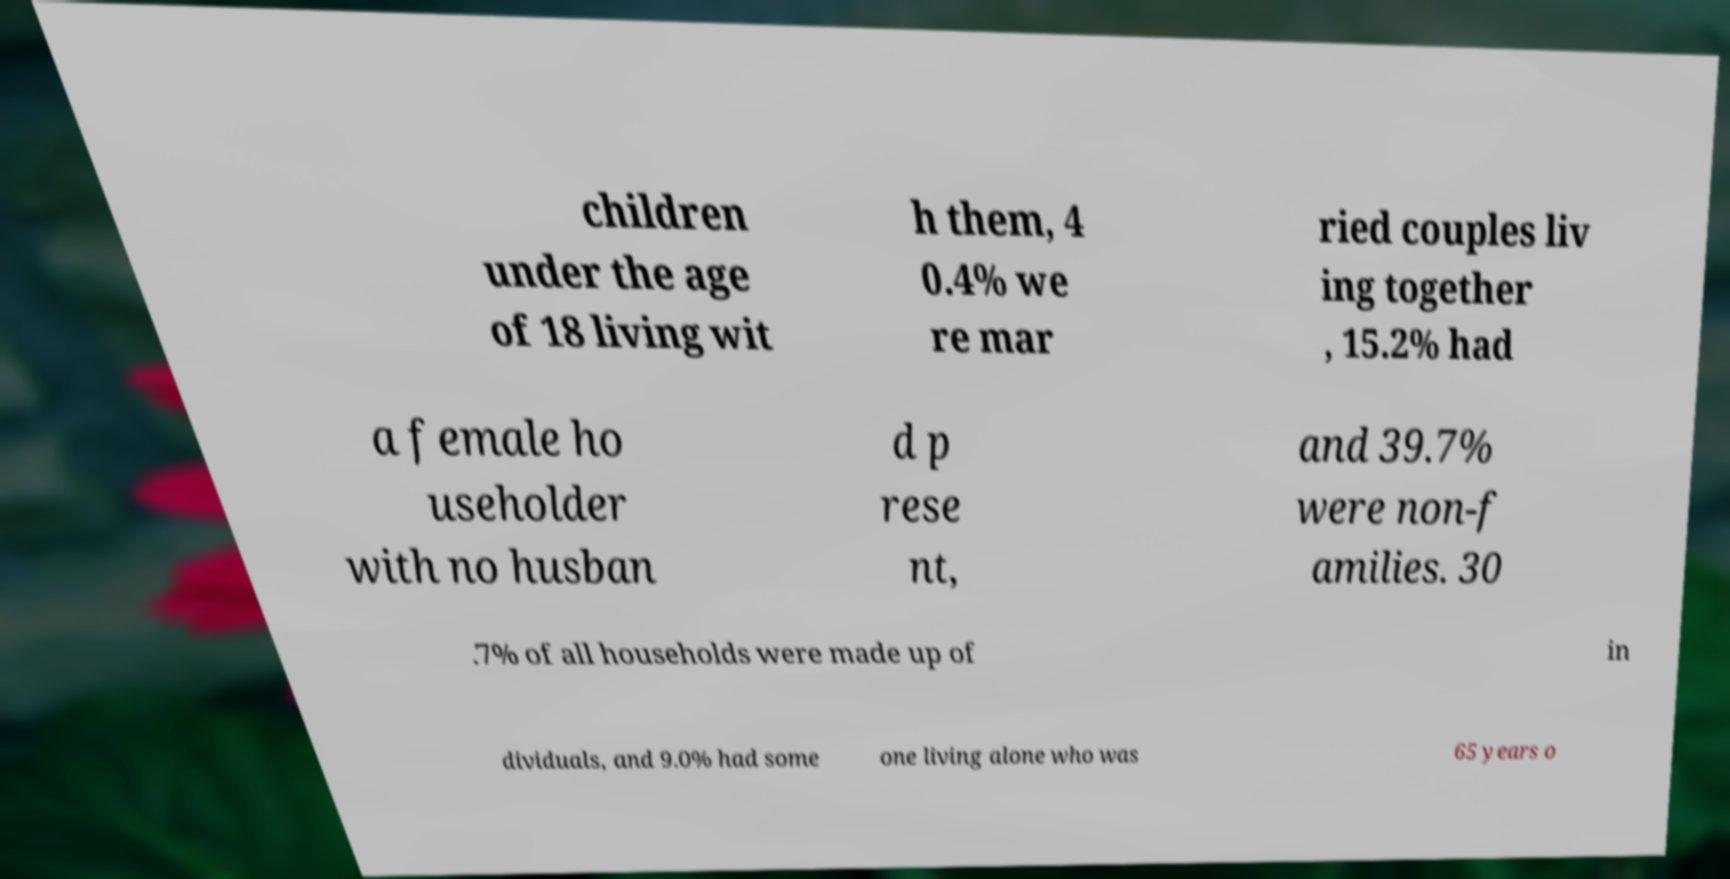Could you assist in decoding the text presented in this image and type it out clearly? children under the age of 18 living wit h them, 4 0.4% we re mar ried couples liv ing together , 15.2% had a female ho useholder with no husban d p rese nt, and 39.7% were non-f amilies. 30 .7% of all households were made up of in dividuals, and 9.0% had some one living alone who was 65 years o 